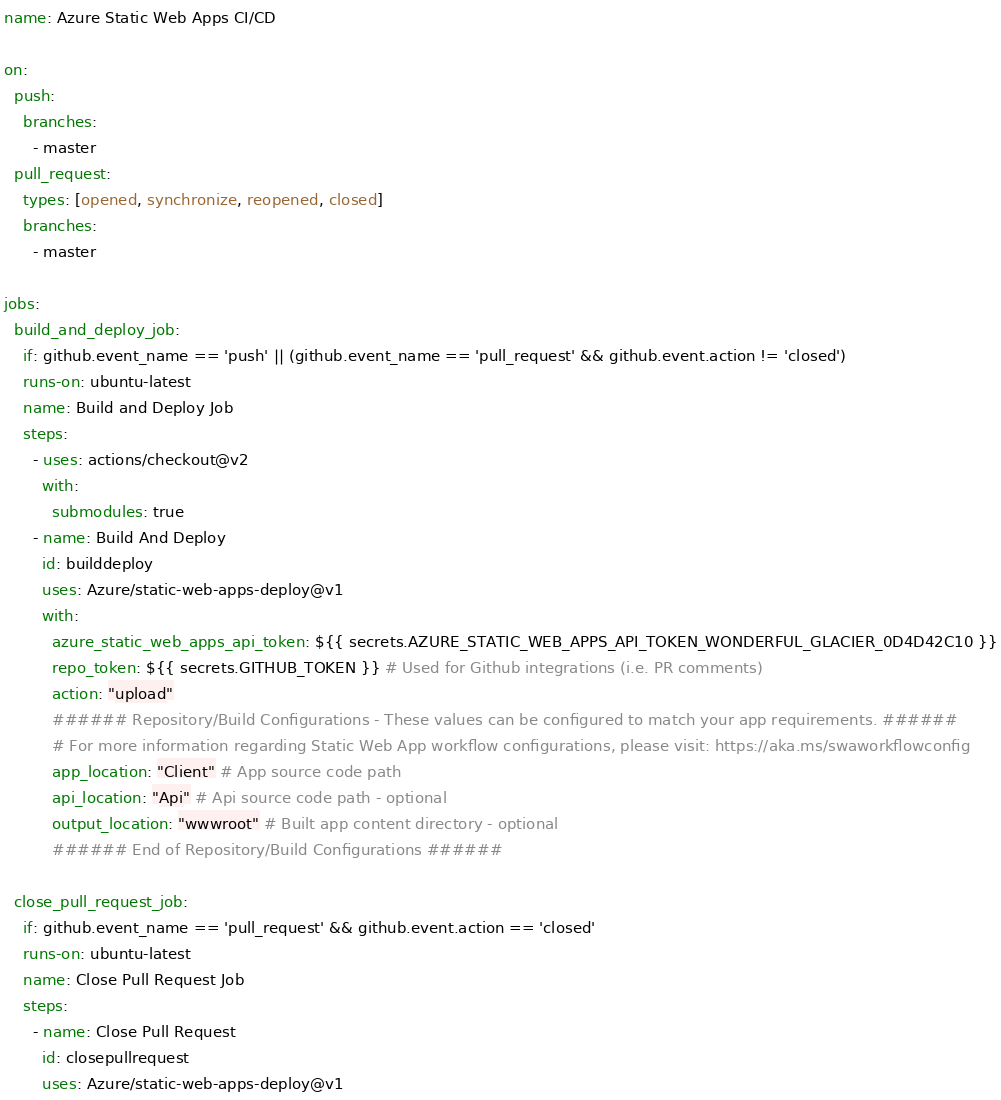<code> <loc_0><loc_0><loc_500><loc_500><_YAML_>name: Azure Static Web Apps CI/CD

on:
  push:
    branches:
      - master
  pull_request:
    types: [opened, synchronize, reopened, closed]
    branches:
      - master

jobs:
  build_and_deploy_job:
    if: github.event_name == 'push' || (github.event_name == 'pull_request' && github.event.action != 'closed')
    runs-on: ubuntu-latest
    name: Build and Deploy Job
    steps:
      - uses: actions/checkout@v2
        with:
          submodules: true
      - name: Build And Deploy
        id: builddeploy
        uses: Azure/static-web-apps-deploy@v1
        with:
          azure_static_web_apps_api_token: ${{ secrets.AZURE_STATIC_WEB_APPS_API_TOKEN_WONDERFUL_GLACIER_0D4D42C10 }}
          repo_token: ${{ secrets.GITHUB_TOKEN }} # Used for Github integrations (i.e. PR comments)
          action: "upload"
          ###### Repository/Build Configurations - These values can be configured to match your app requirements. ######
          # For more information regarding Static Web App workflow configurations, please visit: https://aka.ms/swaworkflowconfig
          app_location: "Client" # App source code path
          api_location: "Api" # Api source code path - optional
          output_location: "wwwroot" # Built app content directory - optional
          ###### End of Repository/Build Configurations ######

  close_pull_request_job:
    if: github.event_name == 'pull_request' && github.event.action == 'closed'
    runs-on: ubuntu-latest
    name: Close Pull Request Job
    steps:
      - name: Close Pull Request
        id: closepullrequest
        uses: Azure/static-web-apps-deploy@v1</code> 